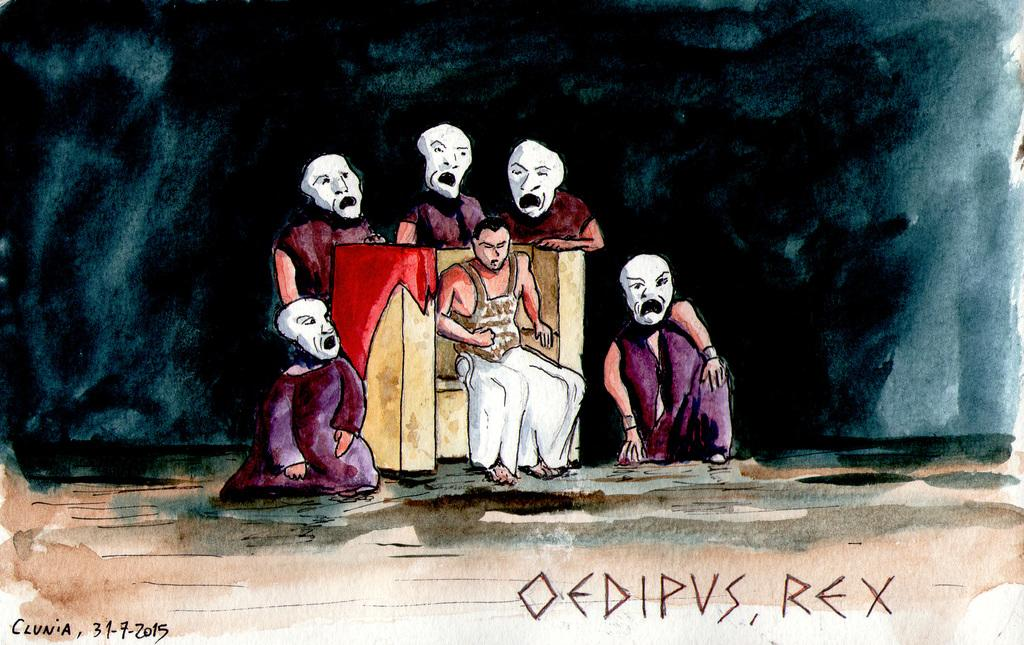What is the main subject of the image? There is a painting in the image. What is happening in the painting? The painting depicts a person sitting on a chair, with people standing and sitting behind the seated person. What type of lock is used to secure the oven in the image? There is no lock or oven present in the image; it features a painting of people sitting and standing. 